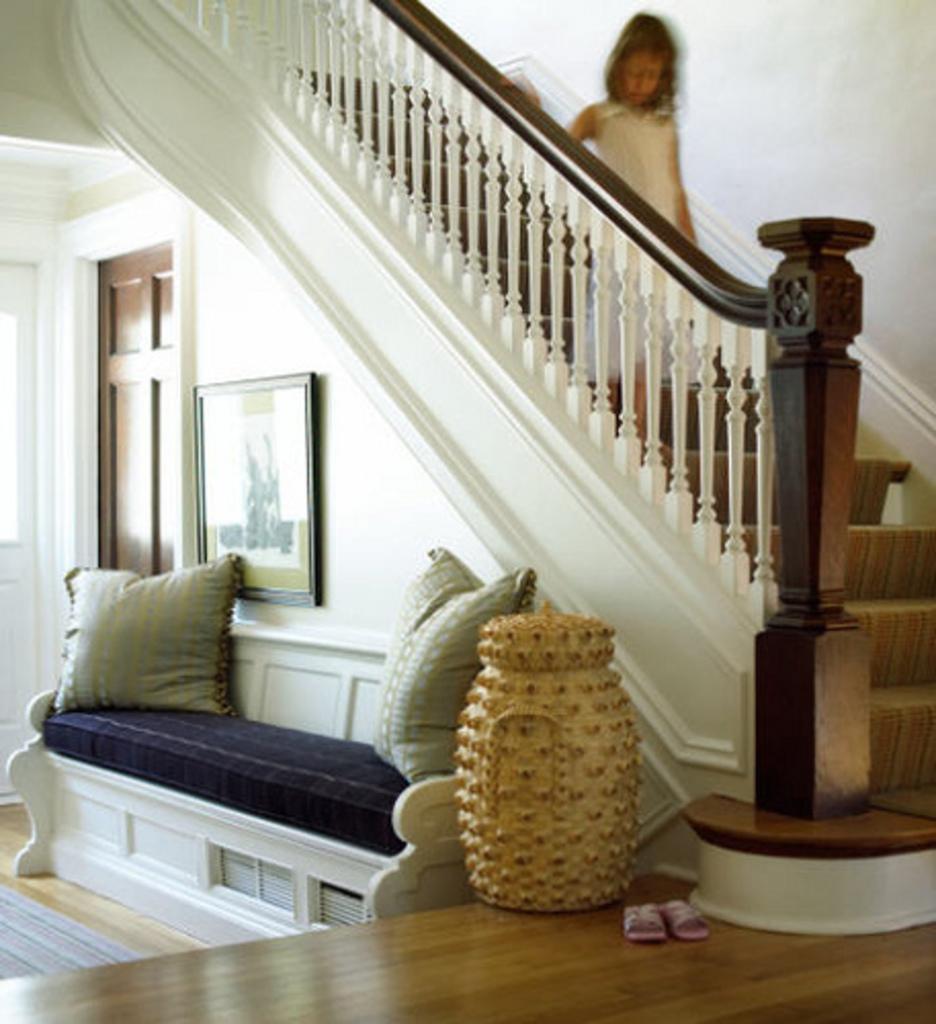Please provide a concise description of this image. In this picture we can see cushions on the sofa bed, beside to it we can see a vase and slippers, on the left side of the image we can see a frame on the wall, at the top of the image we can see a girl. 